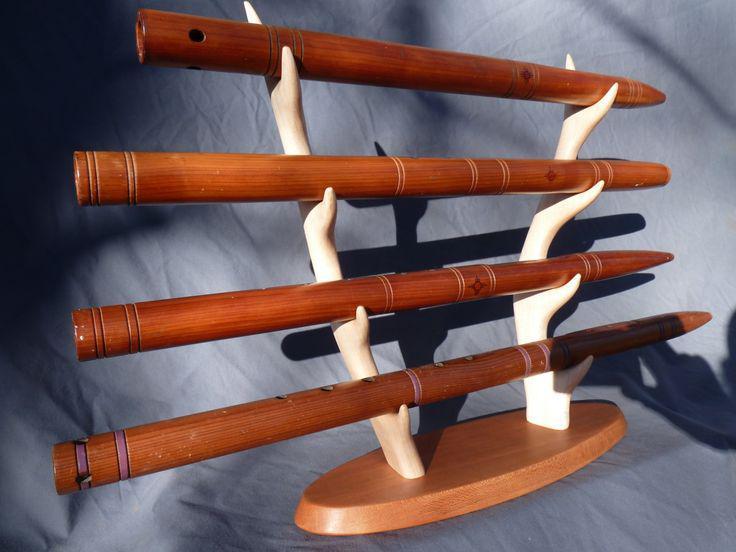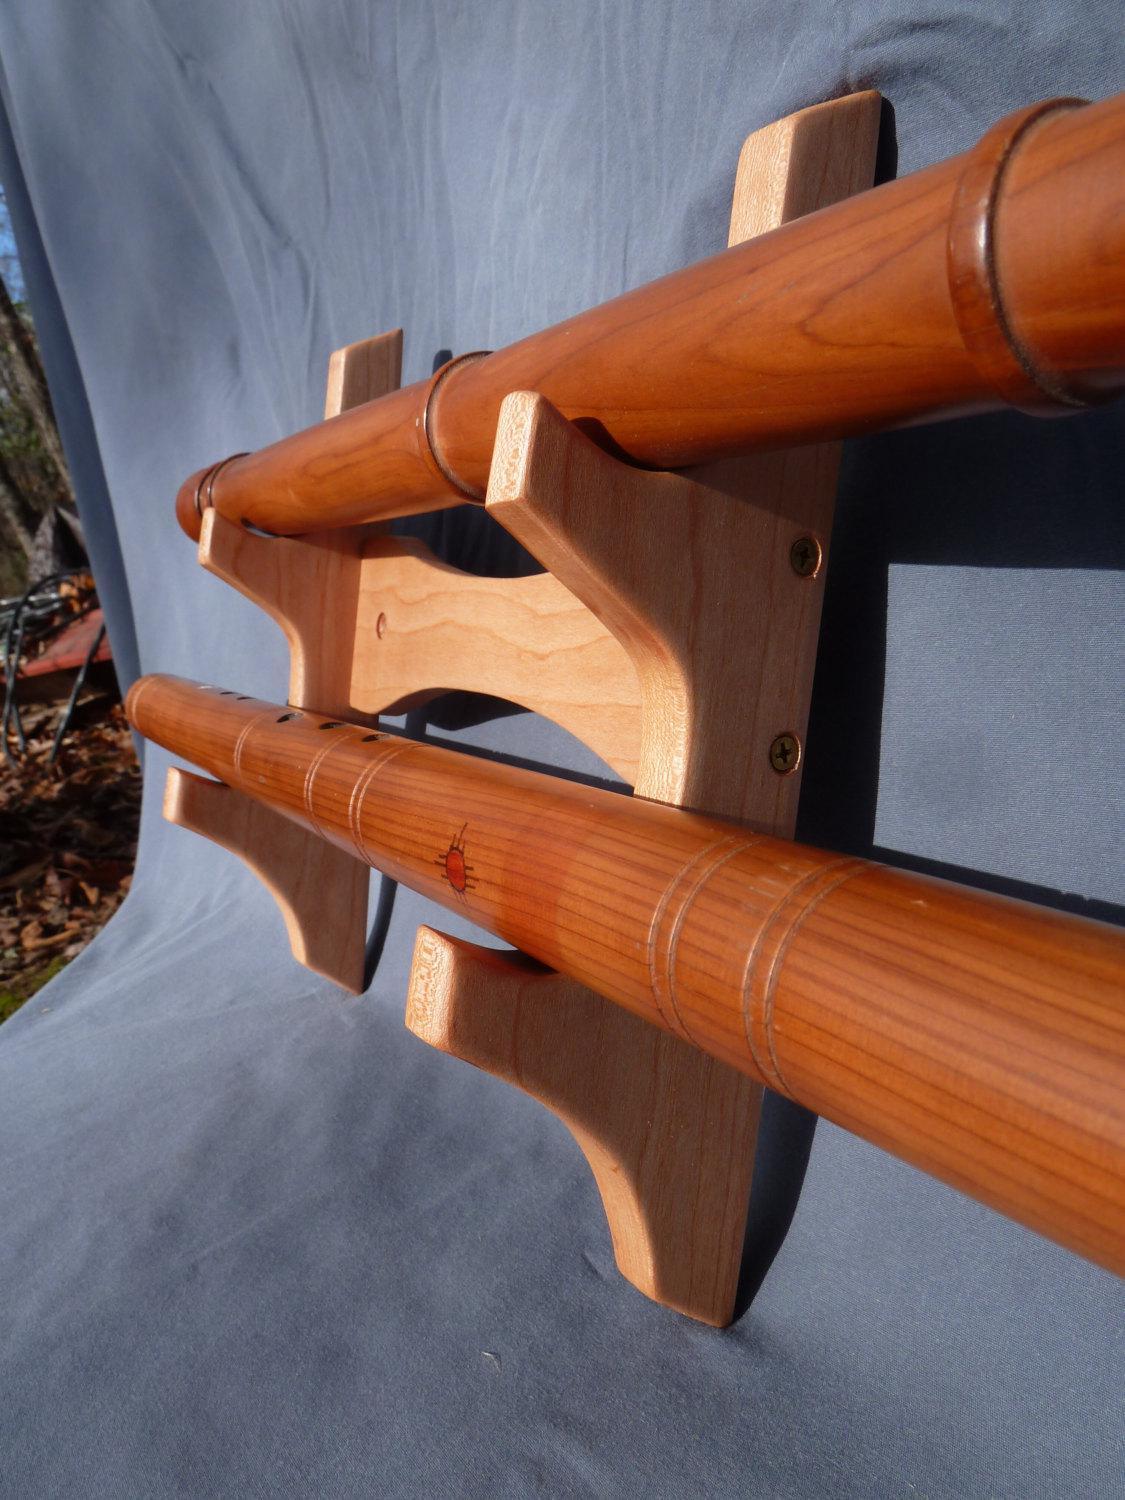The first image is the image on the left, the second image is the image on the right. For the images displayed, is the sentence "Five wooden flutes are displayed horizontally on a stand." factually correct? Answer yes or no. No. 